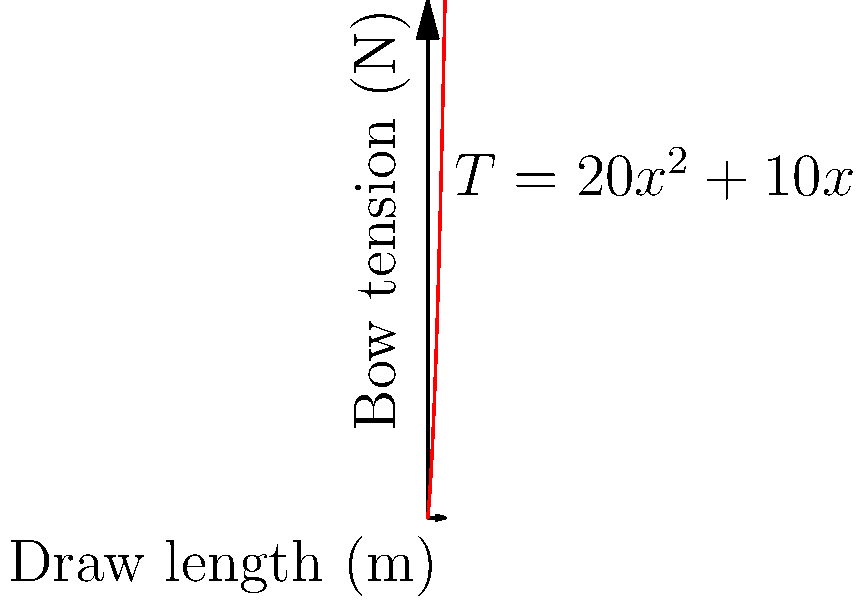As an archer, you're analyzing the tension in your bow during the draw. The tension $T$ (in Newtons) as a function of draw length $x$ (in meters) is given by $T(x) = 20x^2 + 10x$. At what draw length is the rate of change of tension equal to 30 N/m? To solve this problem, we need to follow these steps:

1) The rate of change of tension with respect to draw length is given by the derivative of $T(x)$.

2) Let's find $\frac{dT}{dx}$:
   $\frac{dT}{dx} = \frac{d}{dx}(20x^2 + 10x) = 40x + 10$

3) We want to find the draw length where this rate of change equals 30 N/m:
   $40x + 10 = 30$

4) Solve this equation:
   $40x = 20$
   $x = \frac{20}{40} = 0.5$

5) Therefore, the rate of change of tension is equal to 30 N/m when the draw length is 0.5 meters.
Answer: 0.5 m 